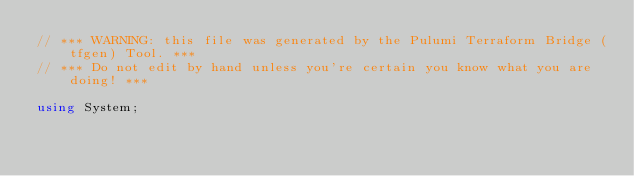Convert code to text. <code><loc_0><loc_0><loc_500><loc_500><_C#_>// *** WARNING: this file was generated by the Pulumi Terraform Bridge (tfgen) Tool. ***
// *** Do not edit by hand unless you're certain you know what you are doing! ***

using System;</code> 